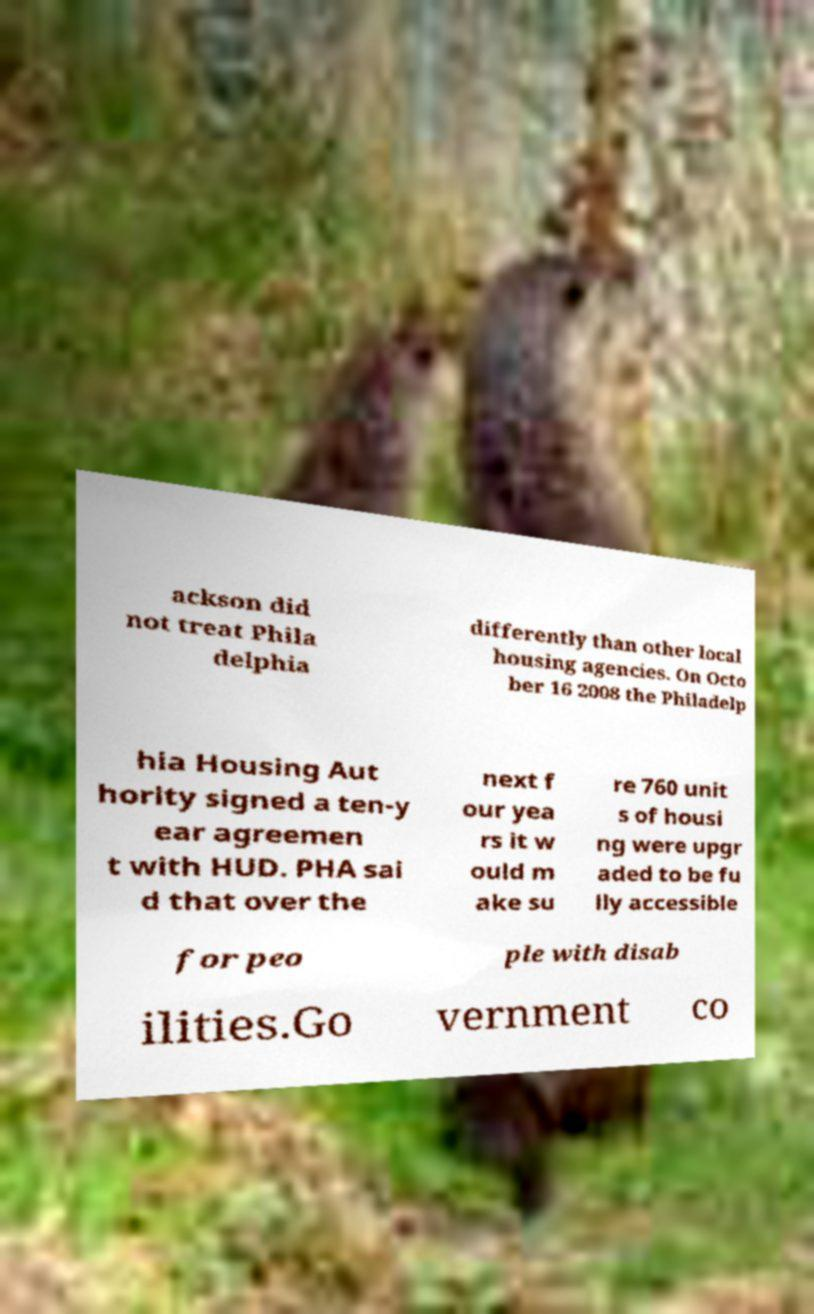Can you accurately transcribe the text from the provided image for me? ackson did not treat Phila delphia differently than other local housing agencies. On Octo ber 16 2008 the Philadelp hia Housing Aut hority signed a ten-y ear agreemen t with HUD. PHA sai d that over the next f our yea rs it w ould m ake su re 760 unit s of housi ng were upgr aded to be fu lly accessible for peo ple with disab ilities.Go vernment co 